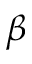<formula> <loc_0><loc_0><loc_500><loc_500>\beta</formula> 